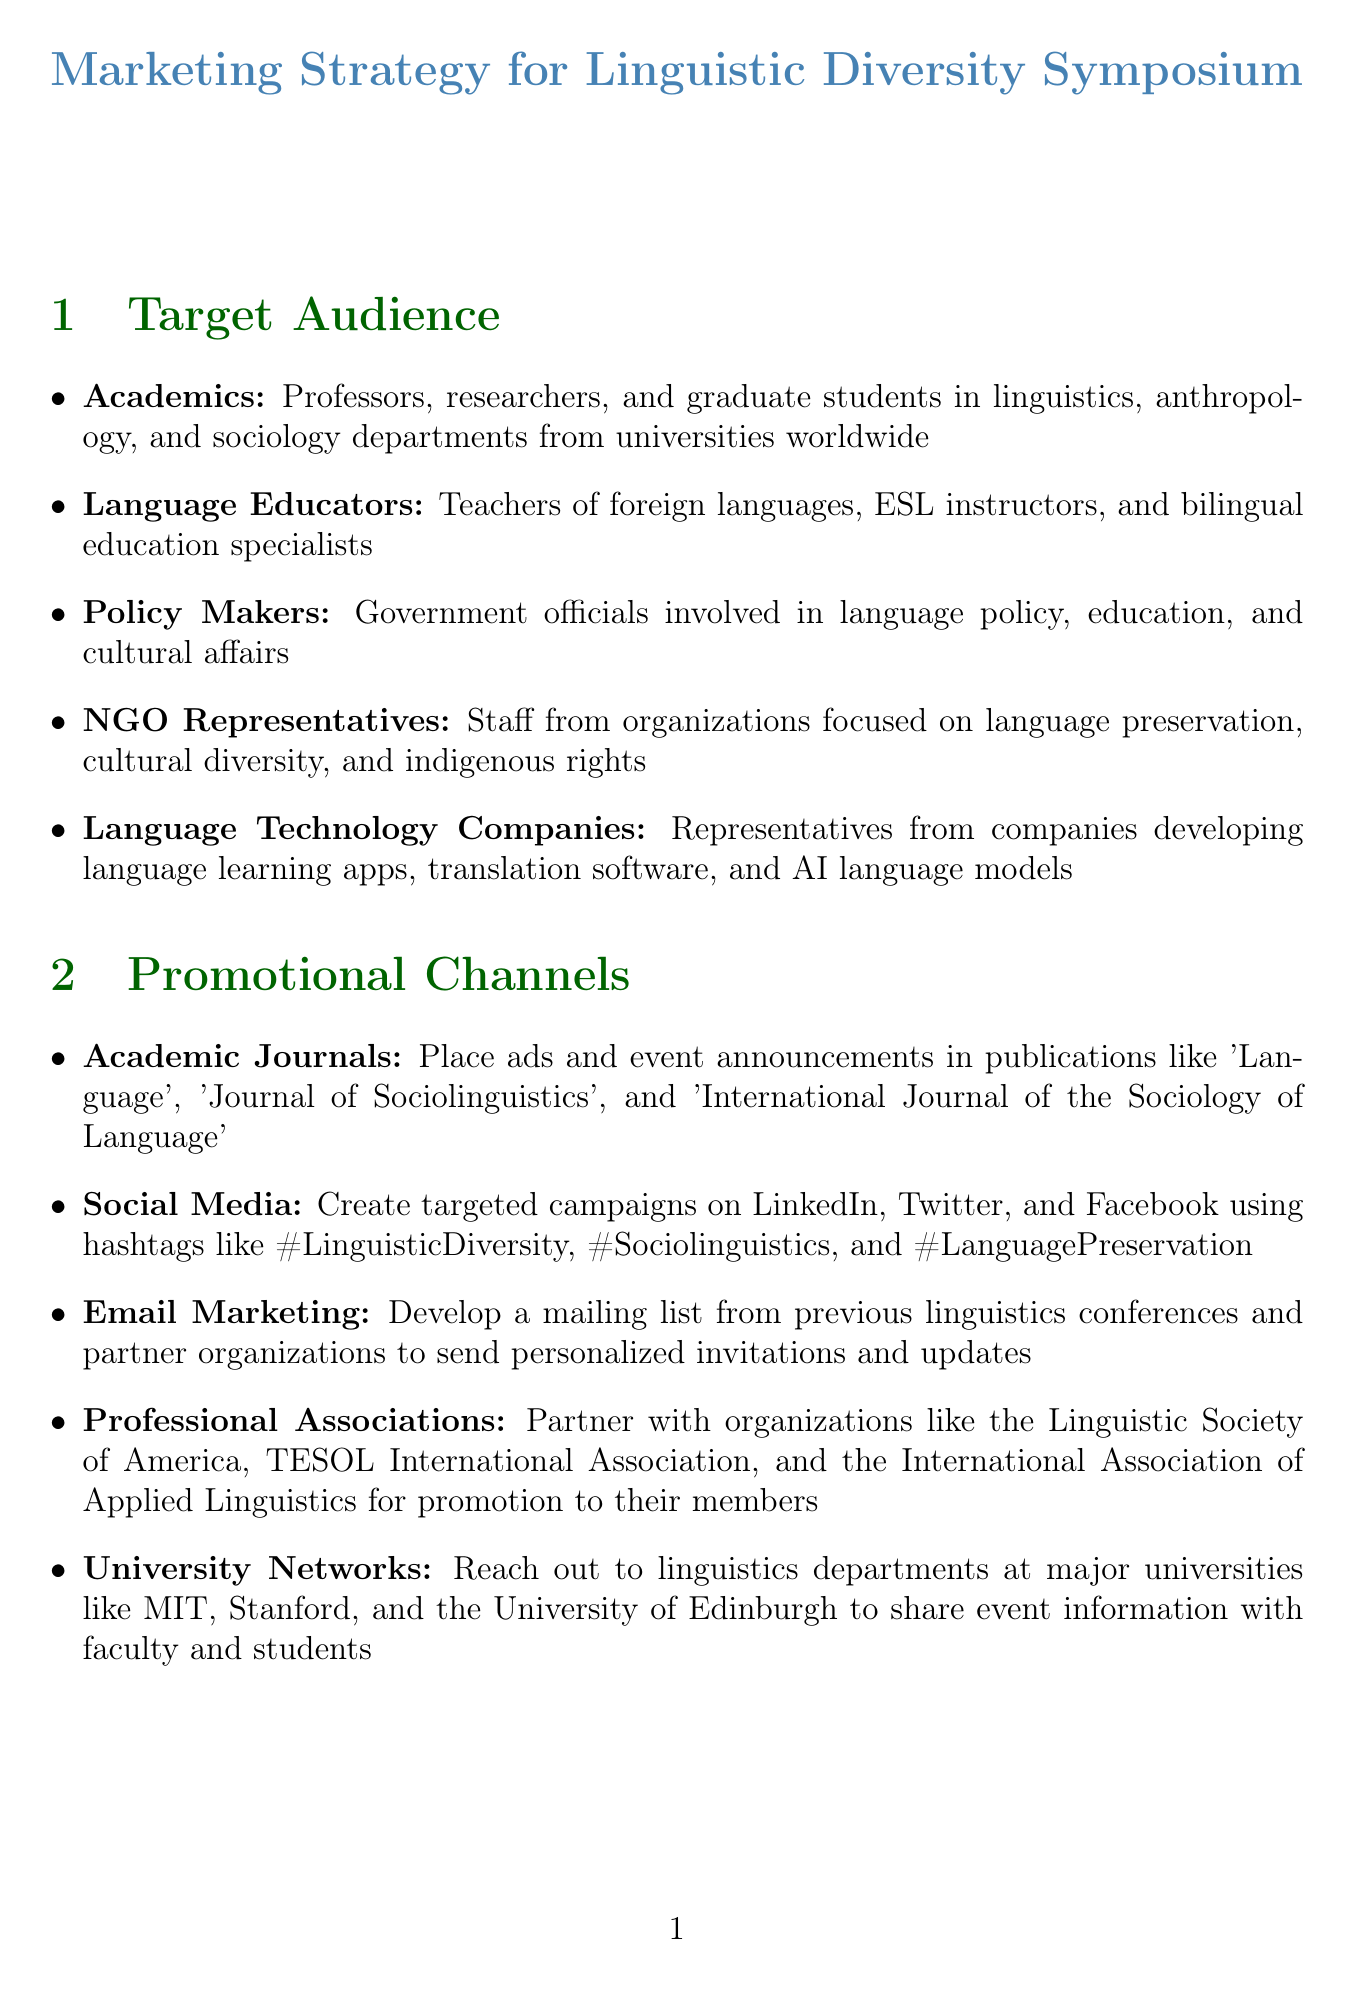What is the title of the report? The title of the report is provided at the top of the document.
Answer: Marketing Strategy for Linguistic Diversity Symposium Who is the keynote speaker? The document lists a keynote speaker in the event highlights section.
Answer: Dr. Deborah Cameron What is the total marketing budget? The marketing budget is stated in the budget section of the document.
Answer: $25,000 How many participants are targeted for registration? The target for attendee registration is specified in the success metrics section.
Answer: 500 participants Which promotional channel involves using hashtags? The promotional channel section describes various channels; one includes hashtags.
Answer: Social Media What is one of the key messages related to technology? Key messaging references different themes; one specifically mentions technology.
Answer: Gain insights into the intersection of technology and linguistic diversity What is the amount allocated for digital advertising? The budget section breaks down the allocation for various categories, including digital advertising.
Answer: $10,000 Which professional association is mentioned for partnership? The document mentions specific organizations in the promotional channels section.
Answer: Linguistic Society of America What is the target satisfaction rate according to the post-event survey? The target satisfaction rate is detailed under success metrics.
Answer: 90% 